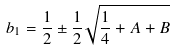Convert formula to latex. <formula><loc_0><loc_0><loc_500><loc_500>b _ { 1 } = \frac { 1 } { 2 } \pm \frac { 1 } { 2 } \sqrt { \frac { 1 } { 4 } + A + B }</formula> 